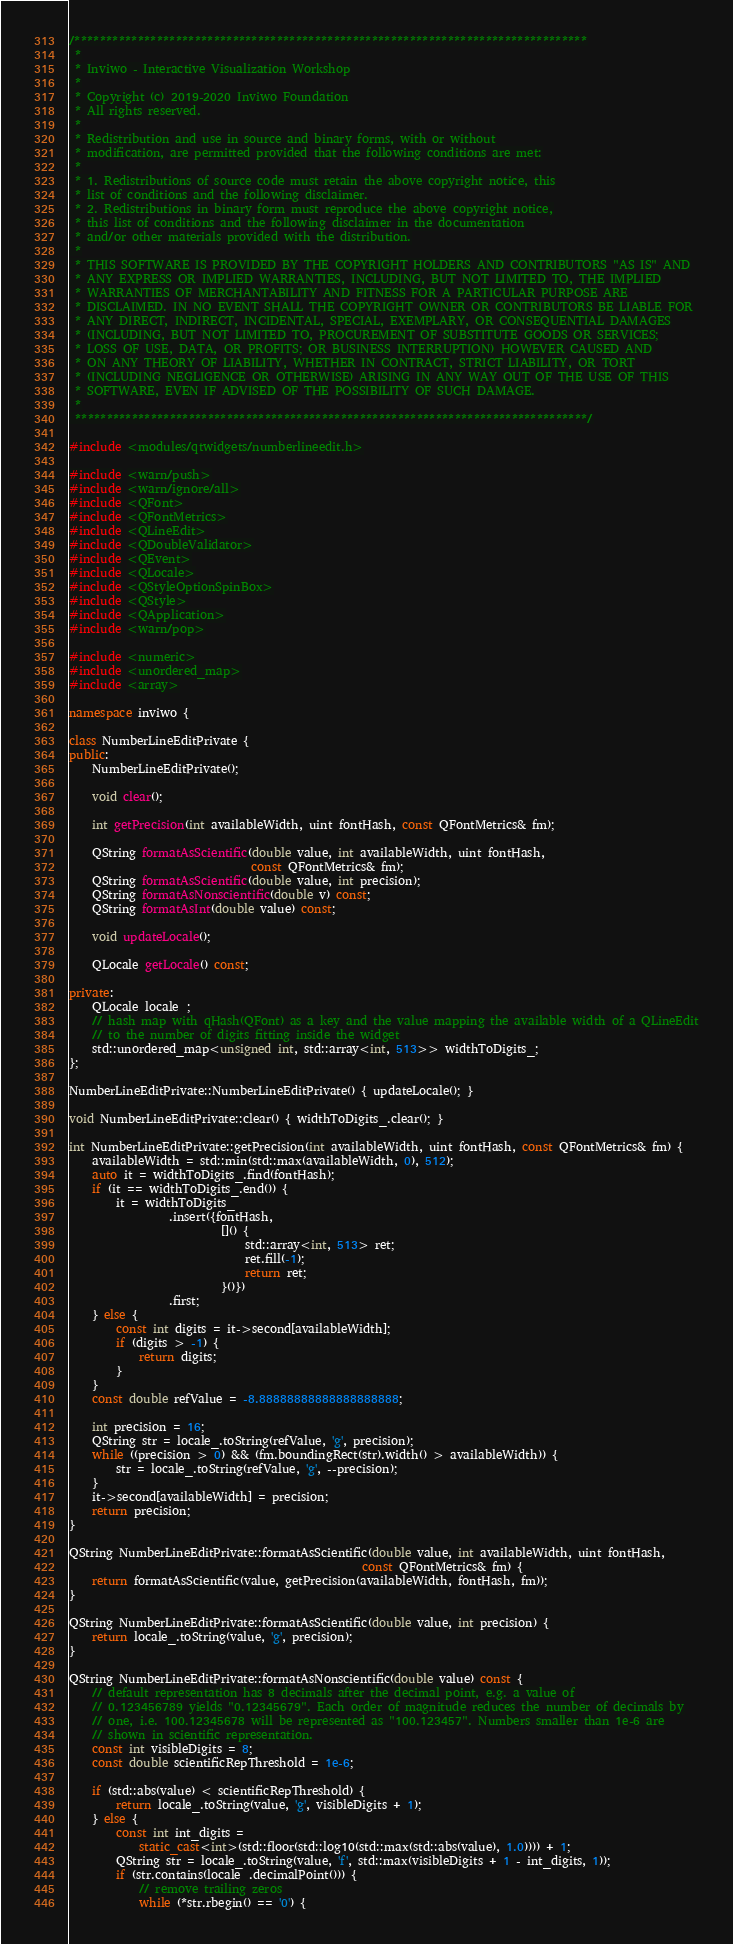<code> <loc_0><loc_0><loc_500><loc_500><_C++_>/*********************************************************************************
 *
 * Inviwo - Interactive Visualization Workshop
 *
 * Copyright (c) 2019-2020 Inviwo Foundation
 * All rights reserved.
 *
 * Redistribution and use in source and binary forms, with or without
 * modification, are permitted provided that the following conditions are met:
 *
 * 1. Redistributions of source code must retain the above copyright notice, this
 * list of conditions and the following disclaimer.
 * 2. Redistributions in binary form must reproduce the above copyright notice,
 * this list of conditions and the following disclaimer in the documentation
 * and/or other materials provided with the distribution.
 *
 * THIS SOFTWARE IS PROVIDED BY THE COPYRIGHT HOLDERS AND CONTRIBUTORS "AS IS" AND
 * ANY EXPRESS OR IMPLIED WARRANTIES, INCLUDING, BUT NOT LIMITED TO, THE IMPLIED
 * WARRANTIES OF MERCHANTABILITY AND FITNESS FOR A PARTICULAR PURPOSE ARE
 * DISCLAIMED. IN NO EVENT SHALL THE COPYRIGHT OWNER OR CONTRIBUTORS BE LIABLE FOR
 * ANY DIRECT, INDIRECT, INCIDENTAL, SPECIAL, EXEMPLARY, OR CONSEQUENTIAL DAMAGES
 * (INCLUDING, BUT NOT LIMITED TO, PROCUREMENT OF SUBSTITUTE GOODS OR SERVICES;
 * LOSS OF USE, DATA, OR PROFITS; OR BUSINESS INTERRUPTION) HOWEVER CAUSED AND
 * ON ANY THEORY OF LIABILITY, WHETHER IN CONTRACT, STRICT LIABILITY, OR TORT
 * (INCLUDING NEGLIGENCE OR OTHERWISE) ARISING IN ANY WAY OUT OF THE USE OF THIS
 * SOFTWARE, EVEN IF ADVISED OF THE POSSIBILITY OF SUCH DAMAGE.
 *
 *********************************************************************************/

#include <modules/qtwidgets/numberlineedit.h>

#include <warn/push>
#include <warn/ignore/all>
#include <QFont>
#include <QFontMetrics>
#include <QLineEdit>
#include <QDoubleValidator>
#include <QEvent>
#include <QLocale>
#include <QStyleOptionSpinBox>
#include <QStyle>
#include <QApplication>
#include <warn/pop>

#include <numeric>
#include <unordered_map>
#include <array>

namespace inviwo {

class NumberLineEditPrivate {
public:
    NumberLineEditPrivate();

    void clear();

    int getPrecision(int availableWidth, uint fontHash, const QFontMetrics& fm);

    QString formatAsScientific(double value, int availableWidth, uint fontHash,
                               const QFontMetrics& fm);
    QString formatAsScientific(double value, int precision);
    QString formatAsNonscientific(double v) const;
    QString formatAsInt(double value) const;

    void updateLocale();

    QLocale getLocale() const;

private:
    QLocale locale_;
    // hash map with qHash(QFont) as a key and the value mapping the available width of a QLineEdit
    // to the number of digits fitting inside the widget
    std::unordered_map<unsigned int, std::array<int, 513>> widthToDigits_;
};

NumberLineEditPrivate::NumberLineEditPrivate() { updateLocale(); }

void NumberLineEditPrivate::clear() { widthToDigits_.clear(); }

int NumberLineEditPrivate::getPrecision(int availableWidth, uint fontHash, const QFontMetrics& fm) {
    availableWidth = std::min(std::max(availableWidth, 0), 512);
    auto it = widthToDigits_.find(fontHash);
    if (it == widthToDigits_.end()) {
        it = widthToDigits_
                 .insert({fontHash,
                          []() {
                              std::array<int, 513> ret;
                              ret.fill(-1);
                              return ret;
                          }()})
                 .first;
    } else {
        const int digits = it->second[availableWidth];
        if (digits > -1) {
            return digits;
        }
    }
    const double refValue = -8.88888888888888888888;

    int precision = 16;
    QString str = locale_.toString(refValue, 'g', precision);
    while ((precision > 0) && (fm.boundingRect(str).width() > availableWidth)) {
        str = locale_.toString(refValue, 'g', --precision);
    }
    it->second[availableWidth] = precision;
    return precision;
}

QString NumberLineEditPrivate::formatAsScientific(double value, int availableWidth, uint fontHash,
                                                  const QFontMetrics& fm) {
    return formatAsScientific(value, getPrecision(availableWidth, fontHash, fm));
}

QString NumberLineEditPrivate::formatAsScientific(double value, int precision) {
    return locale_.toString(value, 'g', precision);
}

QString NumberLineEditPrivate::formatAsNonscientific(double value) const {
    // default representation has 8 decimals after the decimal point, e.g. a value of
    // 0.123456789 yields "0.12345679". Each order of magnitude reduces the number of decimals by
    // one, i.e. 100.12345678 will be represented as "100.123457". Numbers smaller than 1e-6 are
    // shown in scientific representation.
    const int visibleDigits = 8;
    const double scientificRepThreshold = 1e-6;

    if (std::abs(value) < scientificRepThreshold) {
        return locale_.toString(value, 'g', visibleDigits + 1);
    } else {
        const int int_digits =
            static_cast<int>(std::floor(std::log10(std::max(std::abs(value), 1.0)))) + 1;
        QString str = locale_.toString(value, 'f', std::max(visibleDigits + 1 - int_digits, 1));
        if (str.contains(locale_.decimalPoint())) {
            // remove trailing zeros
            while (*str.rbegin() == '0') {</code> 